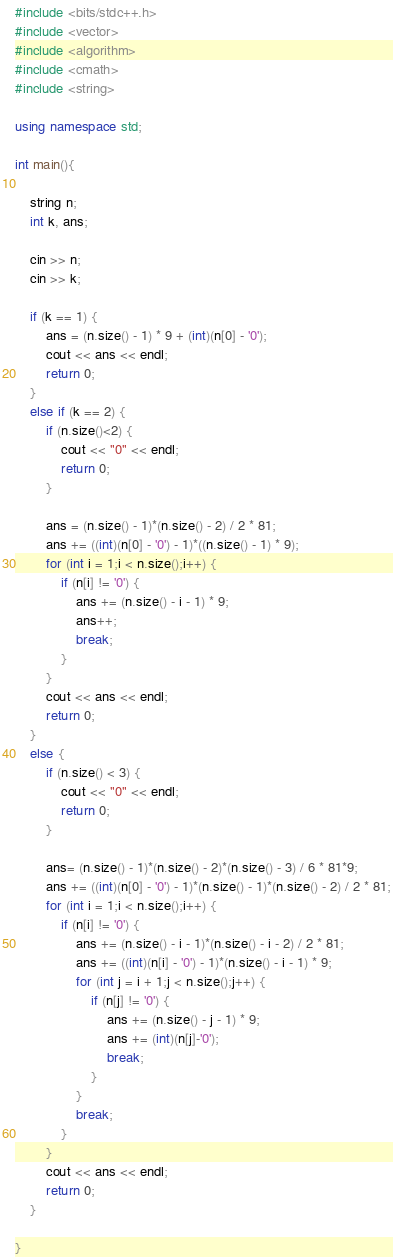Convert code to text. <code><loc_0><loc_0><loc_500><loc_500><_C++_>#include <bits/stdc++.h>
#include <vector>
#include <algorithm>
#include <cmath>
#include <string>

using namespace std;

int main(){

	string n;
	int k, ans;

	cin >> n;
	cin >> k;

	if (k == 1) {
		ans = (n.size() - 1) * 9 + (int)(n[0] - '0');
		cout << ans << endl;
		return 0;
	}
	else if (k == 2) {
		if (n.size()<2) {
			cout << "0" << endl;
			return 0;
		}

		ans = (n.size() - 1)*(n.size() - 2) / 2 * 81;
		ans += ((int)(n[0] - '0') - 1)*((n.size() - 1) * 9);
		for (int i = 1;i < n.size();i++) {
			if (n[i] != '0') {
				ans += (n.size() - i - 1) * 9;
				ans++;
				break;
			}
		}
		cout << ans << endl;
		return 0;
	}
	else {
		if (n.size() < 3) {
			cout << "0" << endl;
			return 0;
		}

		ans= (n.size() - 1)*(n.size() - 2)*(n.size() - 3) / 6 * 81*9;
		ans += ((int)(n[0] - '0') - 1)*(n.size() - 1)*(n.size() - 2) / 2 * 81;
		for (int i = 1;i < n.size();i++) {
			if (n[i] != '0') {
				ans += (n.size() - i - 1)*(n.size() - i - 2) / 2 * 81;
				ans += ((int)(n[i] - '0') - 1)*(n.size() - i - 1) * 9;
				for (int j = i + 1;j < n.size();j++) {
					if (n[j] != '0') {
						ans += (n.size() - j - 1) * 9;
						ans += (int)(n[j]-'0');
						break;
					}
				}
				break;
			}
		}
		cout << ans << endl;
		return 0;
	}

}
</code> 